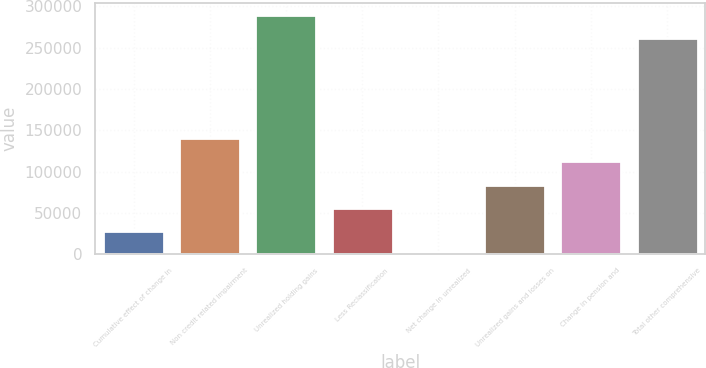<chart> <loc_0><loc_0><loc_500><loc_500><bar_chart><fcel>Cumulative effect of change in<fcel>Non credit related impairment<fcel>Unrealized holding gains<fcel>Less Reclassification<fcel>Net change in unrealized<fcel>Unrealized gains and losses on<fcel>Change in pension and<fcel>Total other comprehensive<nl><fcel>28087.9<fcel>140400<fcel>289784<fcel>56165.8<fcel>10<fcel>84243.7<fcel>112322<fcel>261706<nl></chart> 